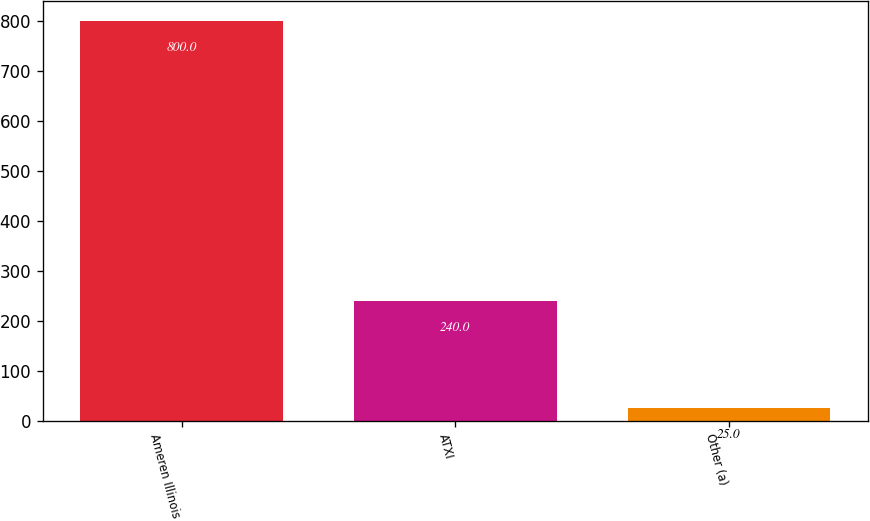Convert chart. <chart><loc_0><loc_0><loc_500><loc_500><bar_chart><fcel>Ameren Illinois<fcel>ATXI<fcel>Other (a)<nl><fcel>800<fcel>240<fcel>25<nl></chart> 